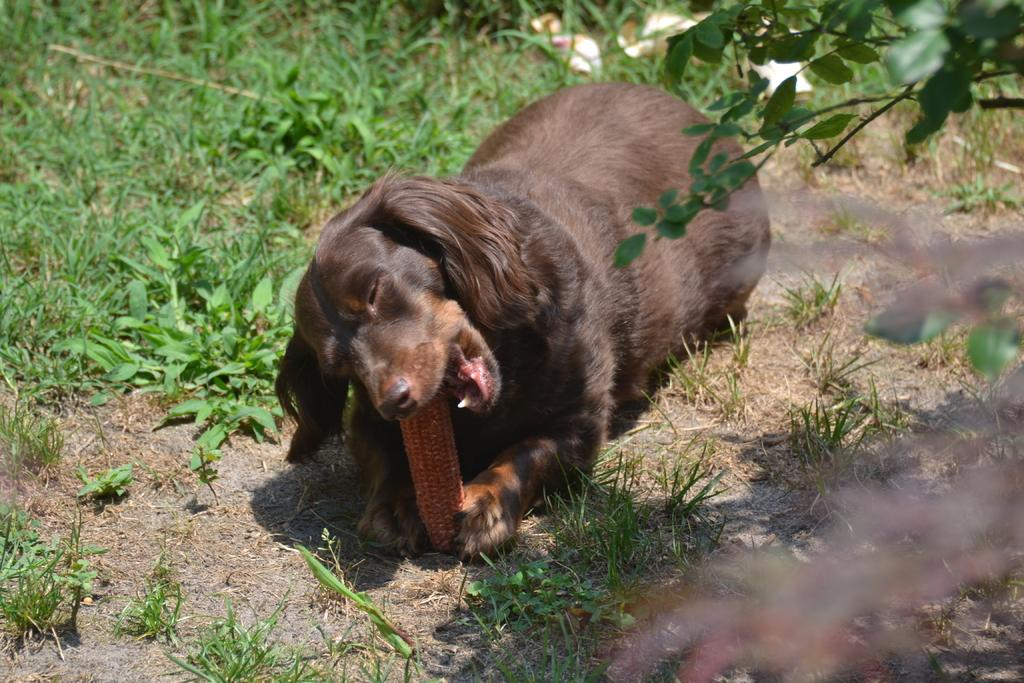What type of animal is in the image? There is a dog in the image. What is the dog doing in the image? The dog is biting a stick in the image. What type of surface is visible in the image? There is grass visible in the image. What other living organisms can be seen in the image? There are plants in the image. What type of bag is the dog carrying in the image? There is no bag present in the image; the dog is biting a stick. What thought is the dog having while biting the stick in the image? It is impossible to determine the dog's thoughts from the image. 